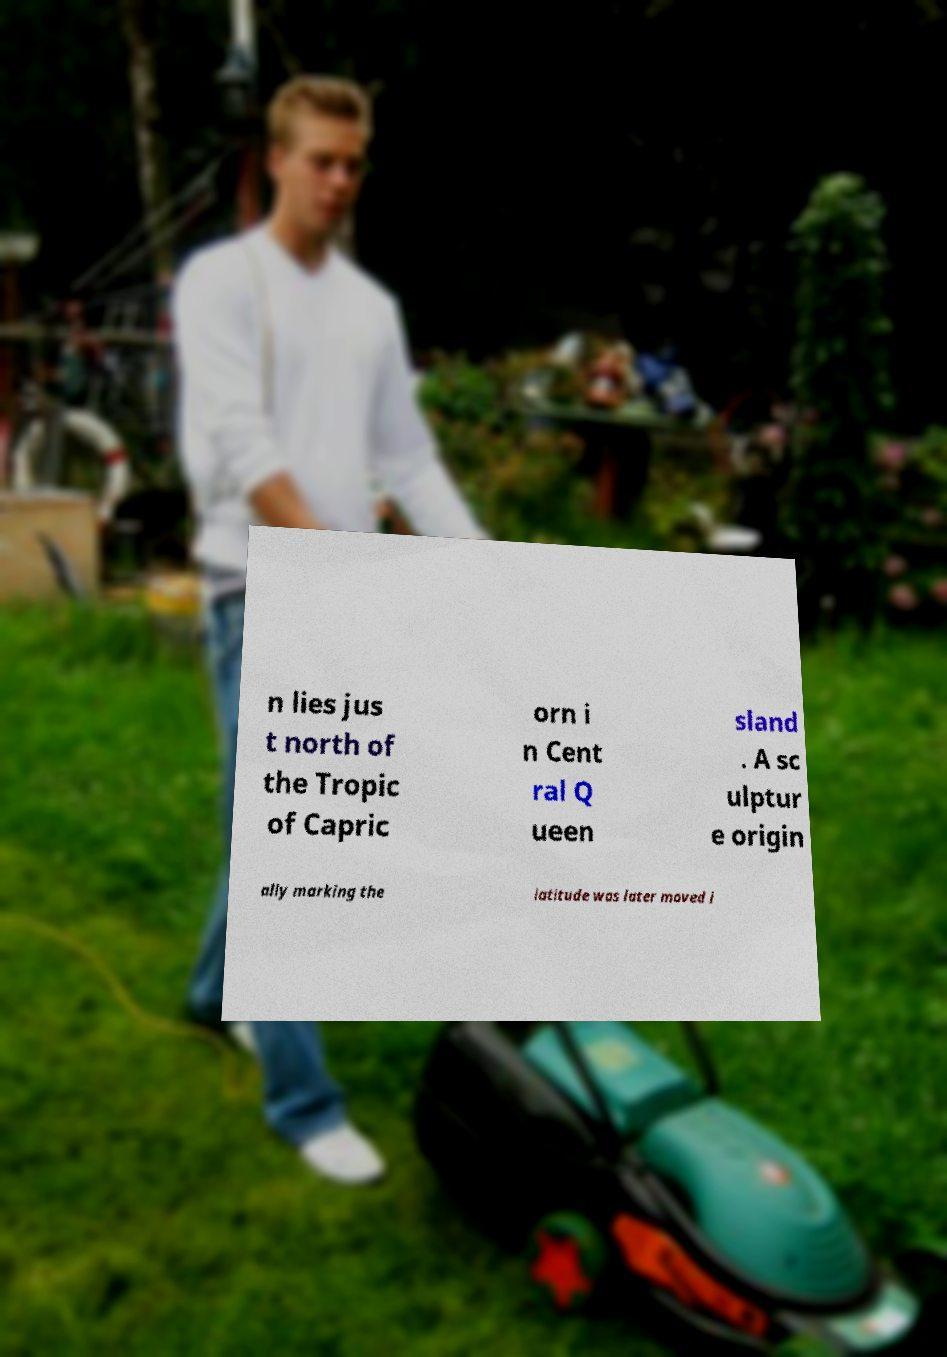Could you extract and type out the text from this image? n lies jus t north of the Tropic of Capric orn i n Cent ral Q ueen sland . A sc ulptur e origin ally marking the latitude was later moved i 